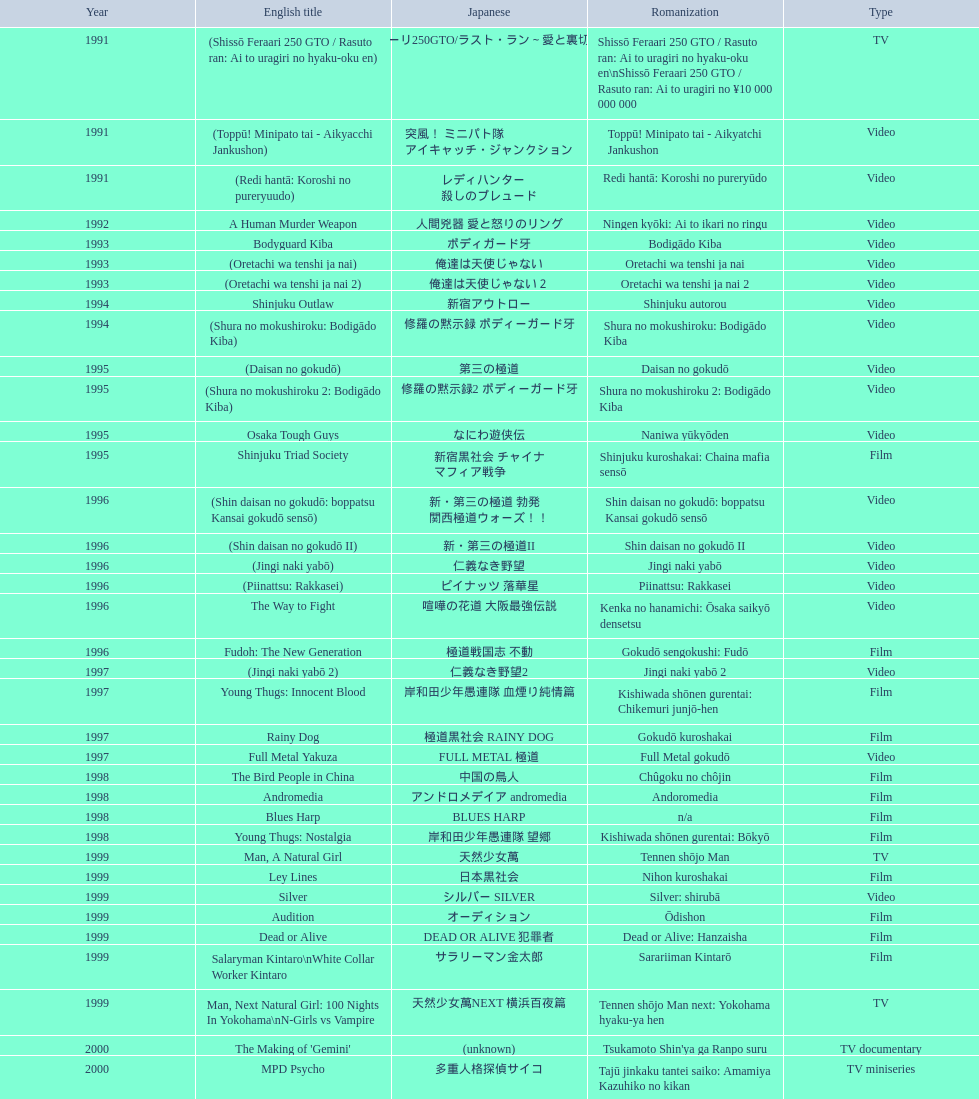Was shinjuku triad society a film or tv release? Film. 